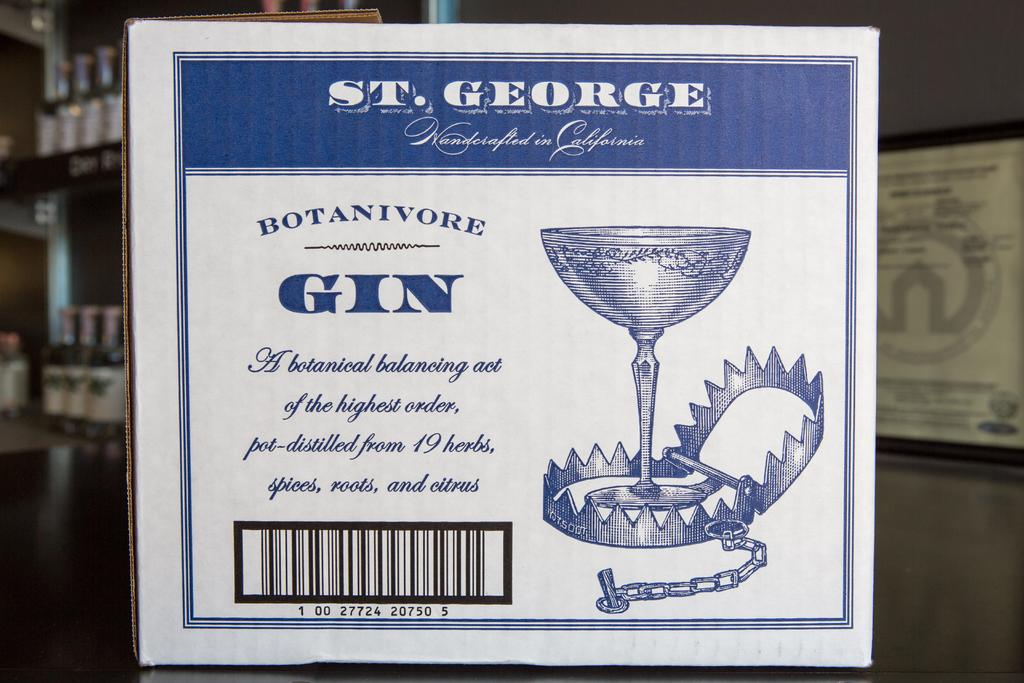What is featured on the poster in the image? There is a poster with text in the image. What can be seen on the shelves in the image? There are many bottles present on shelves in the image. How does the honey fall from the match in the image? There is no honey or match present in the image. What type of honey is dripping from the match in the image? There is no honey or match present in the image, so it is not possible to determine the type of honey. 